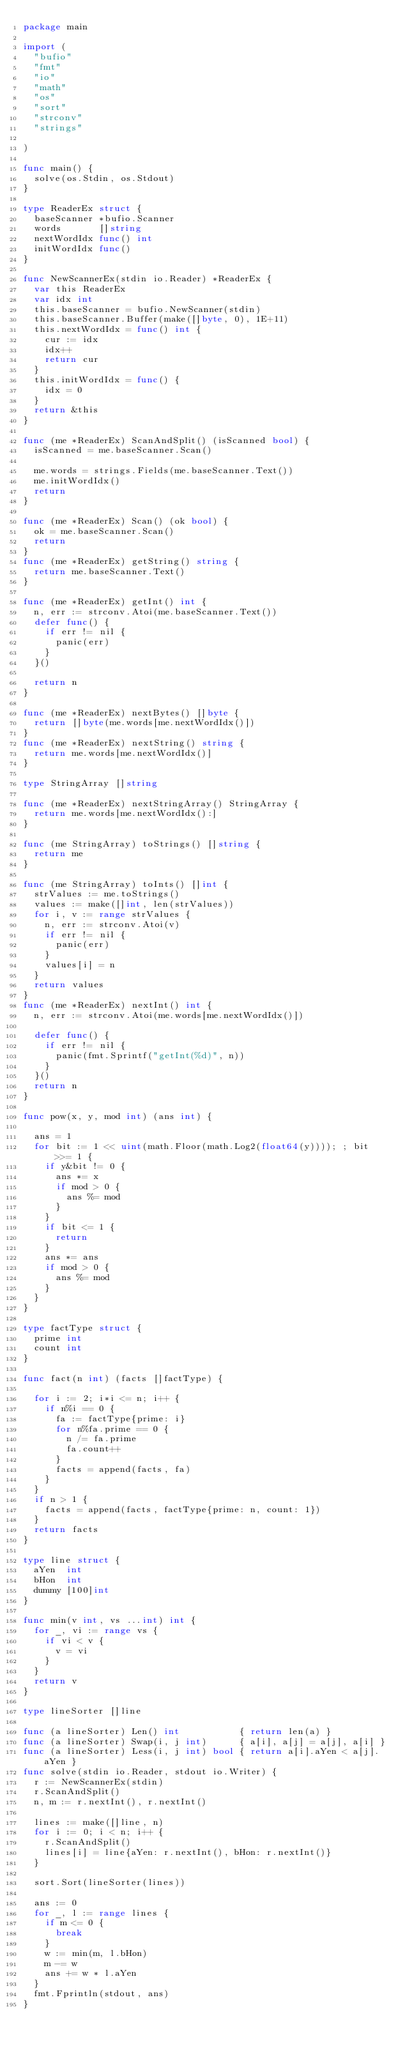<code> <loc_0><loc_0><loc_500><loc_500><_Go_>package main

import (
	"bufio"
	"fmt"
	"io"
	"math"
	"os"
	"sort"
	"strconv"
	"strings"

)

func main() {
	solve(os.Stdin, os.Stdout)
}

type ReaderEx struct {
	baseScanner *bufio.Scanner
	words       []string
	nextWordIdx func() int
	initWordIdx func()
}

func NewScannerEx(stdin io.Reader) *ReaderEx {
	var this ReaderEx
	var idx int
	this.baseScanner = bufio.NewScanner(stdin)
	this.baseScanner.Buffer(make([]byte, 0), 1E+11)
	this.nextWordIdx = func() int {
		cur := idx
		idx++
		return cur
	}
	this.initWordIdx = func() {
		idx = 0
	}
	return &this
}

func (me *ReaderEx) ScanAndSplit() (isScanned bool) {
	isScanned = me.baseScanner.Scan()

	me.words = strings.Fields(me.baseScanner.Text())
	me.initWordIdx()
	return
}

func (me *ReaderEx) Scan() (ok bool) {
	ok = me.baseScanner.Scan()
	return
}
func (me *ReaderEx) getString() string {
	return me.baseScanner.Text()
}

func (me *ReaderEx) getInt() int {
	n, err := strconv.Atoi(me.baseScanner.Text())
	defer func() {
		if err != nil {
			panic(err)
		}
	}()

	return n
}

func (me *ReaderEx) nextBytes() []byte {
	return []byte(me.words[me.nextWordIdx()])
}
func (me *ReaderEx) nextString() string {
	return me.words[me.nextWordIdx()]
}

type StringArray []string

func (me *ReaderEx) nextStringArray() StringArray {
	return me.words[me.nextWordIdx():]
}

func (me StringArray) toStrings() []string {
	return me
}

func (me StringArray) toInts() []int {
	strValues := me.toStrings()
	values := make([]int, len(strValues))
	for i, v := range strValues {
		n, err := strconv.Atoi(v)
		if err != nil {
			panic(err)
		}
		values[i] = n
	}
	return values
}
func (me *ReaderEx) nextInt() int {
	n, err := strconv.Atoi(me.words[me.nextWordIdx()])

	defer func() {
		if err != nil {
			panic(fmt.Sprintf("getInt(%d)", n))
		}
	}()
	return n
}

func pow(x, y, mod int) (ans int) {

	ans = 1
	for bit := 1 << uint(math.Floor(math.Log2(float64(y)))); ; bit >>= 1 {
		if y&bit != 0 {
			ans *= x
			if mod > 0 {
				ans %= mod
			}
		}
		if bit <= 1 {
			return
		}
		ans *= ans
		if mod > 0 {
			ans %= mod
		}
	}
}

type factType struct {
	prime int
	count int
}

func fact(n int) (facts []factType) {

	for i := 2; i*i <= n; i++ {
		if n%i == 0 {
			fa := factType{prime: i}
			for n%fa.prime == 0 {
				n /= fa.prime
				fa.count++
			}
			facts = append(facts, fa)
		}
	}
	if n > 1 {
		facts = append(facts, factType{prime: n, count: 1})
	}
	return facts
}

type line struct {
	aYen  int
	bHon  int
	dummy [100]int
}

func min(v int, vs ...int) int {
	for _, vi := range vs {
		if vi < v {
			v = vi
		}
	}
	return v
}

type lineSorter []line

func (a lineSorter) Len() int           { return len(a) }
func (a lineSorter) Swap(i, j int)      { a[i], a[j] = a[j], a[i] }
func (a lineSorter) Less(i, j int) bool { return a[i].aYen < a[j].aYen }
func solve(stdin io.Reader, stdout io.Writer) {
	r := NewScannerEx(stdin)
	r.ScanAndSplit()
	n, m := r.nextInt(), r.nextInt()

	lines := make([]line, n)
	for i := 0; i < n; i++ {
		r.ScanAndSplit()
		lines[i] = line{aYen: r.nextInt(), bHon: r.nextInt()}
	}

	sort.Sort(lineSorter(lines))

	ans := 0
	for _, l := range lines {
		if m <= 0 {
			break
		}
		w := min(m, l.bHon)
		m -= w
		ans += w * l.aYen
	}
	fmt.Fprintln(stdout, ans)
}

</code> 